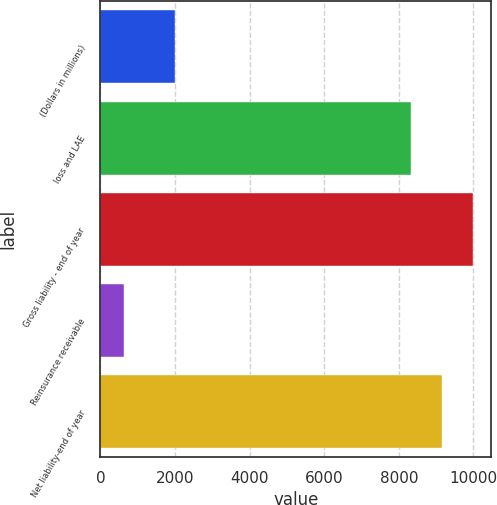Convert chart. <chart><loc_0><loc_0><loc_500><loc_500><bar_chart><fcel>(Dollars in millions)<fcel>loss and LAE<fcel>Gross liability - end of year<fcel>Reinsurance receivable<fcel>Net liability-end of year<nl><fcel>2009<fcel>8315.9<fcel>9979.08<fcel>641.5<fcel>9147.49<nl></chart> 